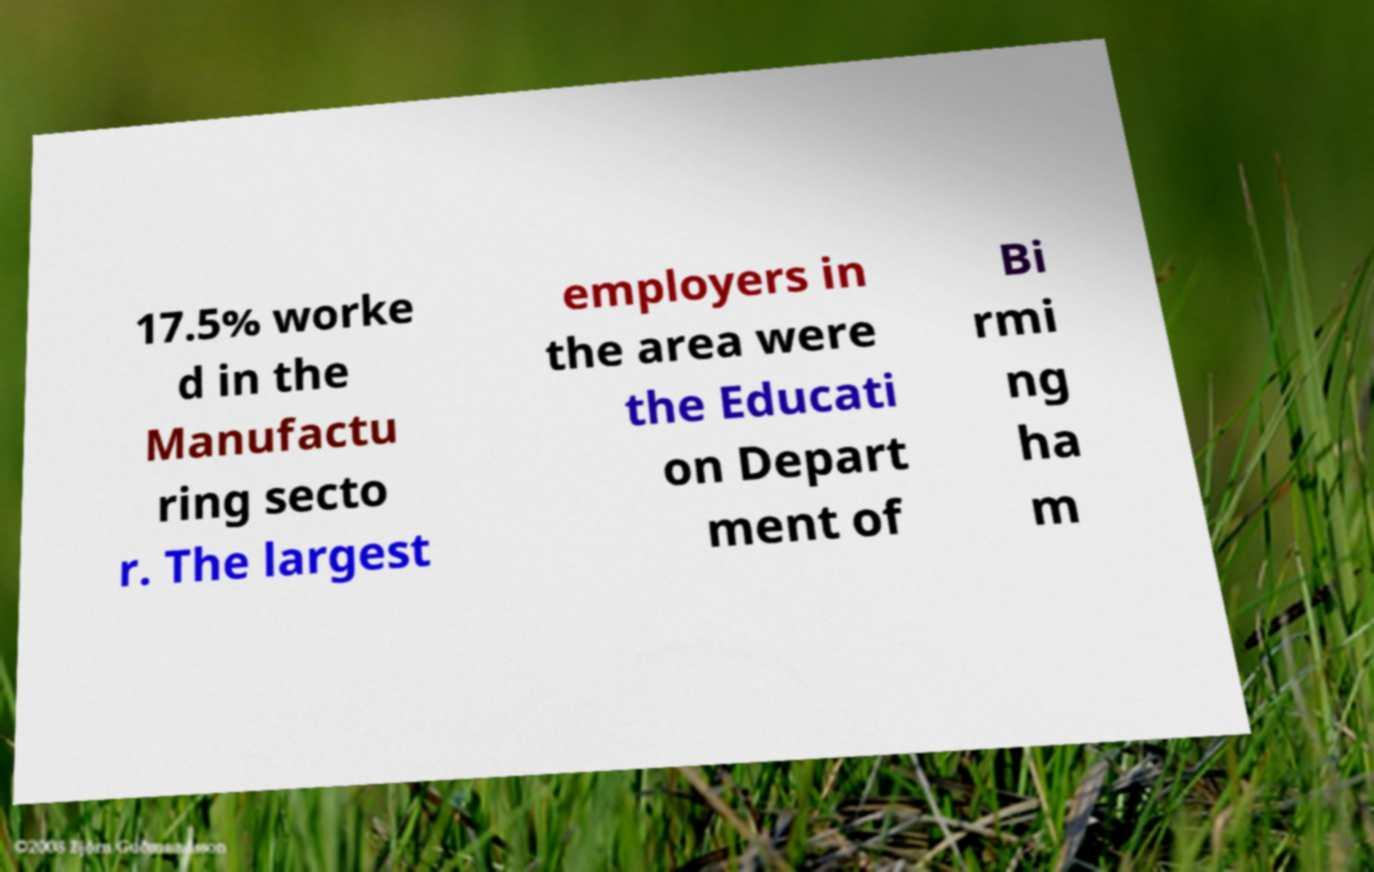Can you read and provide the text displayed in the image?This photo seems to have some interesting text. Can you extract and type it out for me? 17.5% worke d in the Manufactu ring secto r. The largest employers in the area were the Educati on Depart ment of Bi rmi ng ha m 